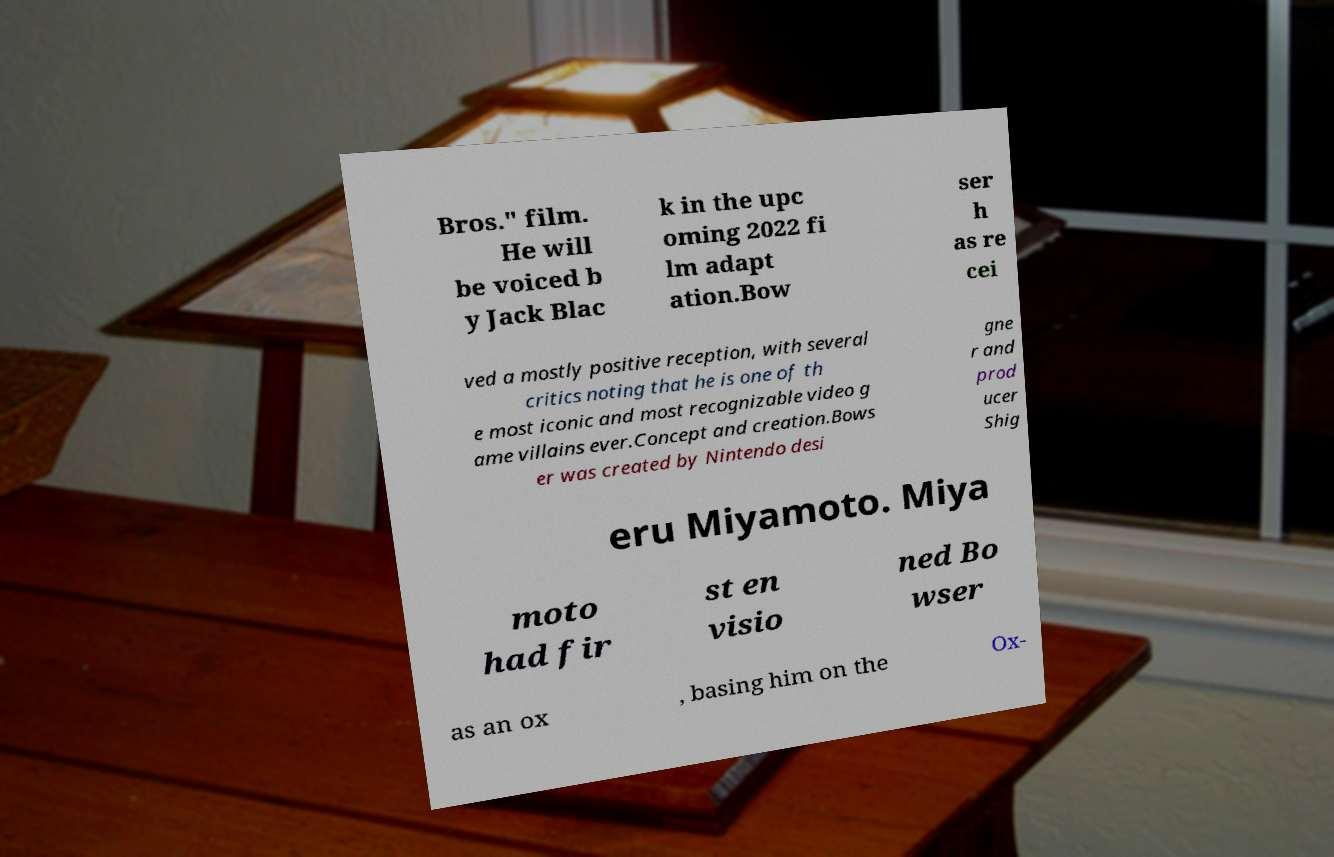There's text embedded in this image that I need extracted. Can you transcribe it verbatim? Bros." film. He will be voiced b y Jack Blac k in the upc oming 2022 fi lm adapt ation.Bow ser h as re cei ved a mostly positive reception, with several critics noting that he is one of th e most iconic and most recognizable video g ame villains ever.Concept and creation.Bows er was created by Nintendo desi gne r and prod ucer Shig eru Miyamoto. Miya moto had fir st en visio ned Bo wser as an ox , basing him on the Ox- 